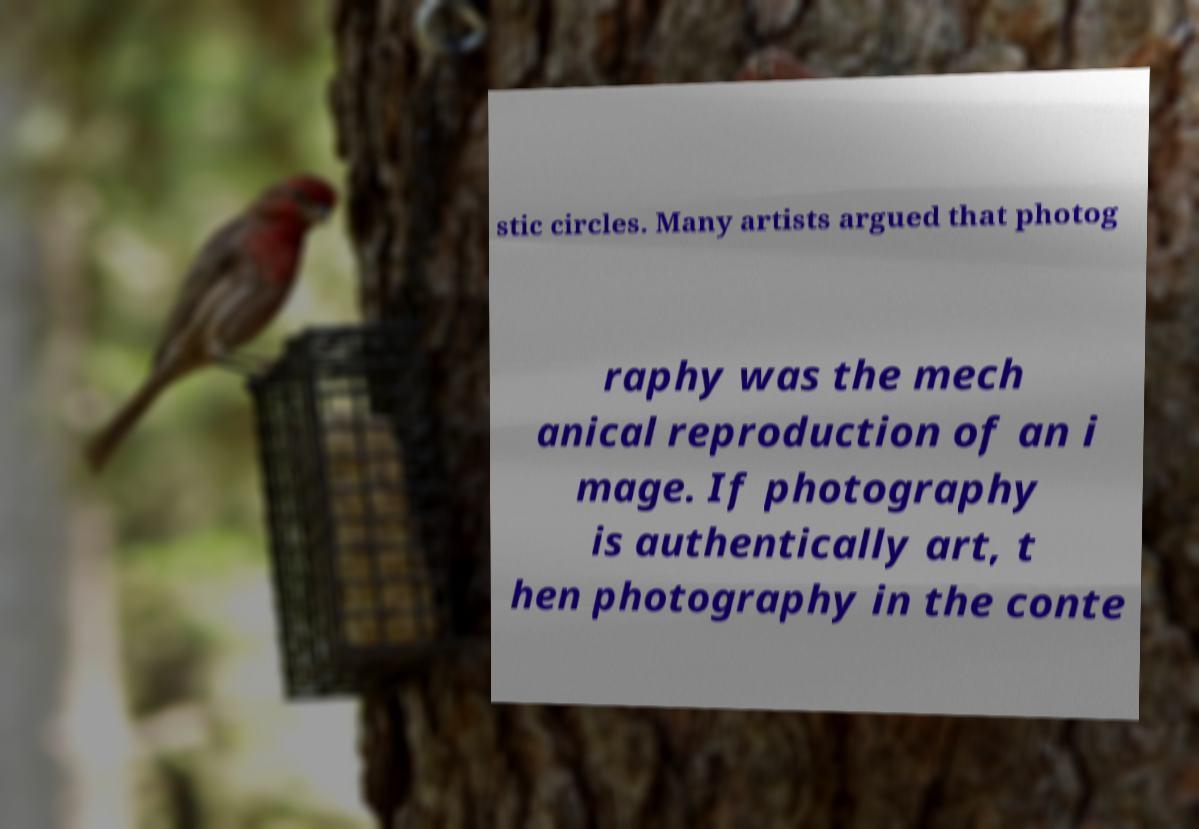I need the written content from this picture converted into text. Can you do that? stic circles. Many artists argued that photog raphy was the mech anical reproduction of an i mage. If photography is authentically art, t hen photography in the conte 